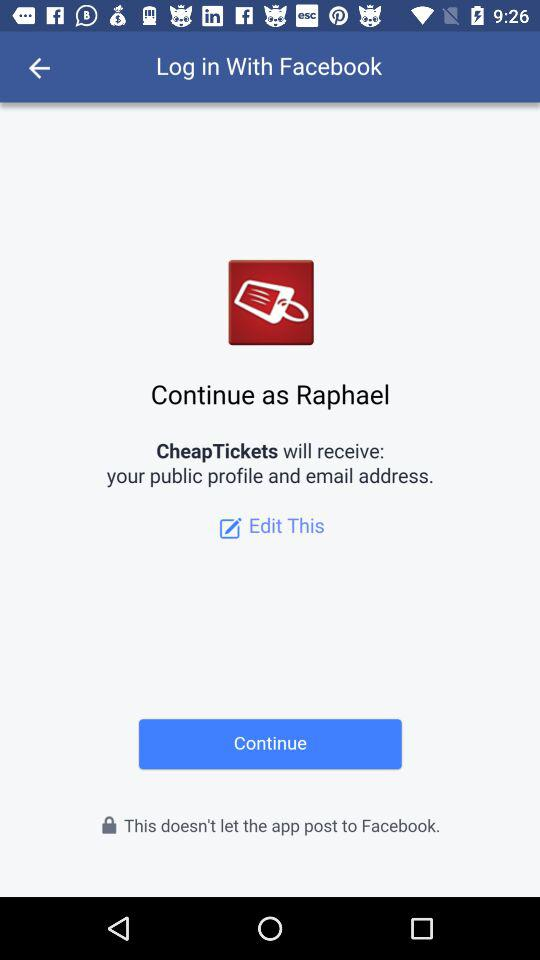What application will receive my public profile and email address? The application "CheapTickets" will receive your public profile and email address. 